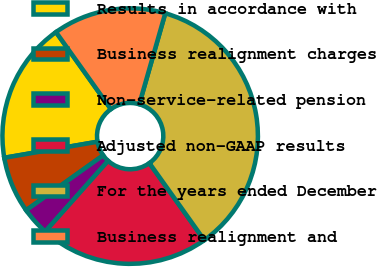Convert chart to OTSL. <chart><loc_0><loc_0><loc_500><loc_500><pie_chart><fcel>Results in accordance with<fcel>Business realignment charges<fcel>Non-service-related pension<fcel>Adjusted non-GAAP results<fcel>For the years ended December<fcel>Business realignment and<nl><fcel>17.86%<fcel>7.14%<fcel>3.57%<fcel>21.43%<fcel>35.71%<fcel>14.29%<nl></chart> 